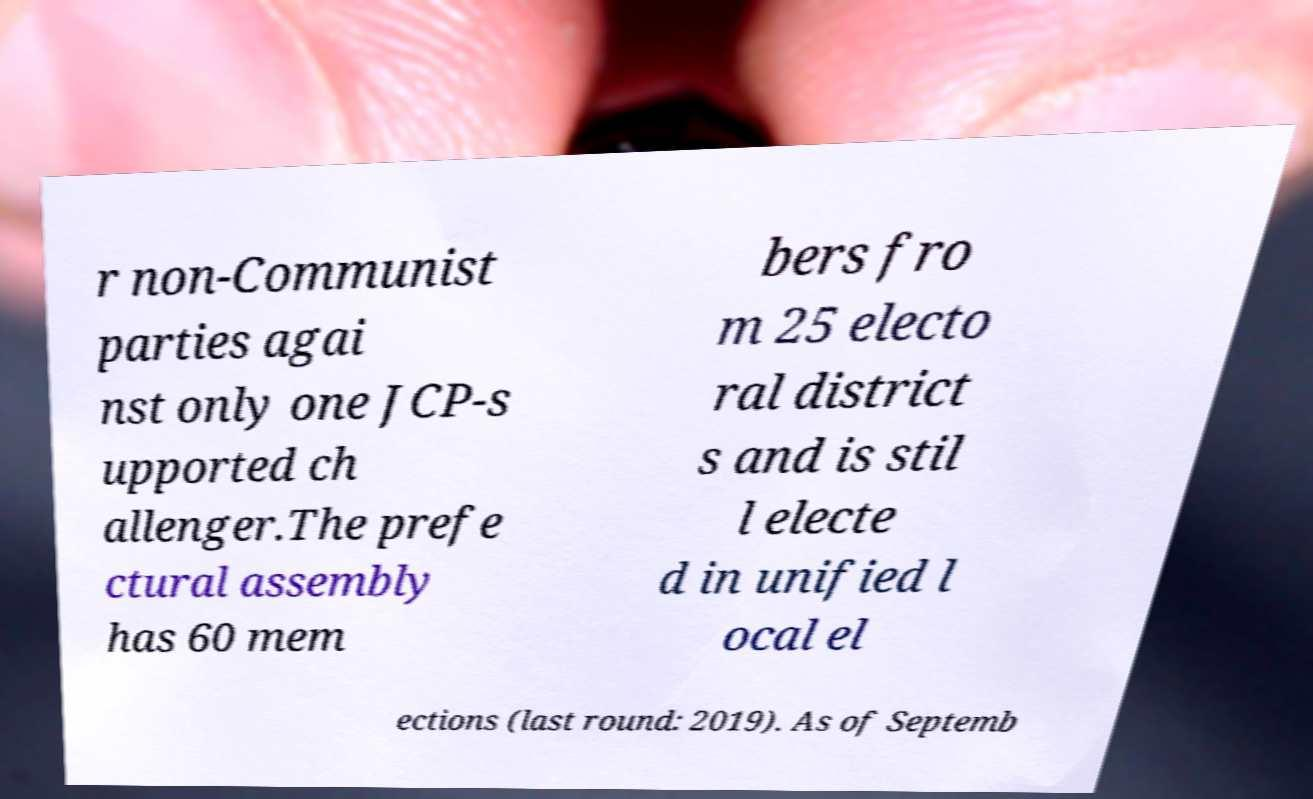Could you extract and type out the text from this image? r non-Communist parties agai nst only one JCP-s upported ch allenger.The prefe ctural assembly has 60 mem bers fro m 25 electo ral district s and is stil l electe d in unified l ocal el ections (last round: 2019). As of Septemb 